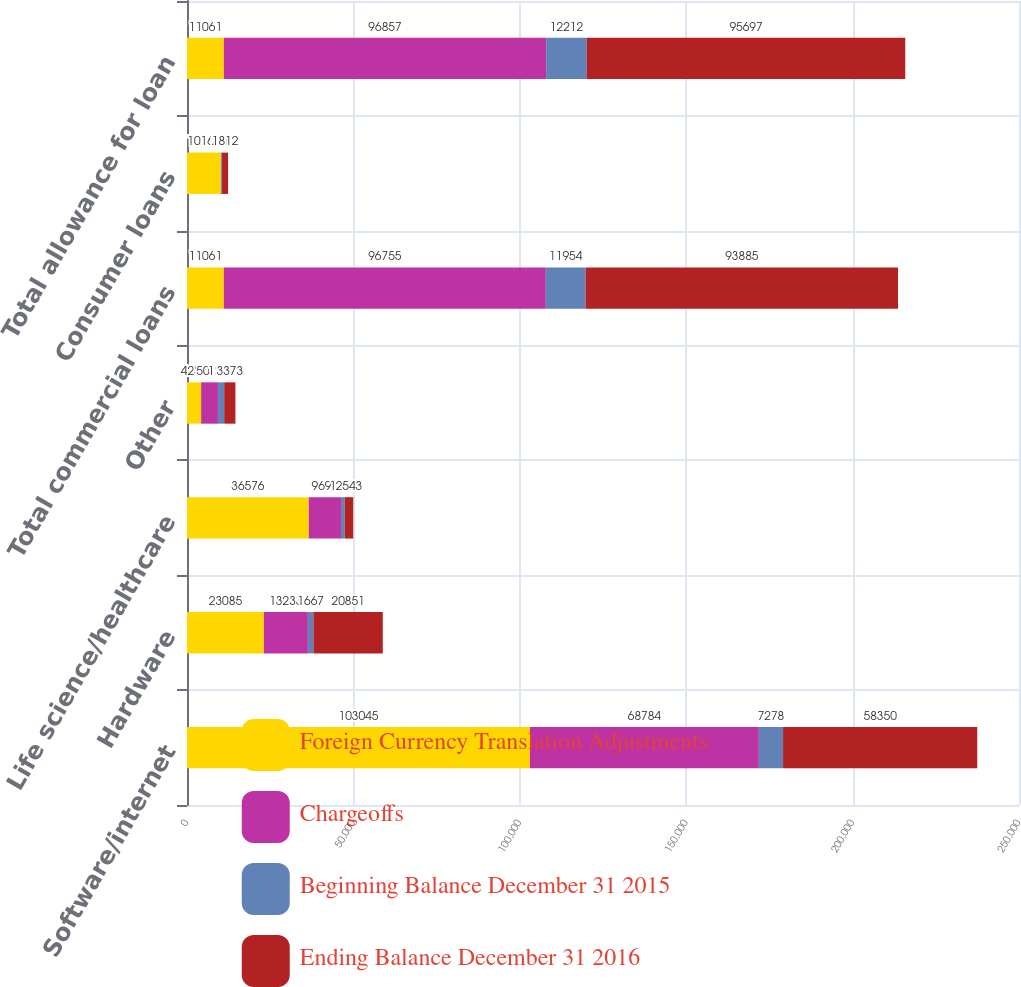<chart> <loc_0><loc_0><loc_500><loc_500><stacked_bar_chart><ecel><fcel>Software/internet<fcel>Hardware<fcel>Life science/healthcare<fcel>Other<fcel>Total commercial loans<fcel>Consumer loans<fcel>Total allowance for loan<nl><fcel>Foreign Currency Translation Adjustments<fcel>103045<fcel>23085<fcel>36576<fcel>4252<fcel>11061<fcel>10168<fcel>11061<nl><fcel>Chargeoffs<fcel>68784<fcel>13233<fcel>9693<fcel>5045<fcel>96755<fcel>102<fcel>96857<nl><fcel>Beginning Balance December 31 2015<fcel>7278<fcel>1667<fcel>1129<fcel>1880<fcel>11954<fcel>258<fcel>12212<nl><fcel>Ending Balance December 31 2016<fcel>58350<fcel>20851<fcel>2543<fcel>3373<fcel>93885<fcel>1812<fcel>95697<nl></chart> 